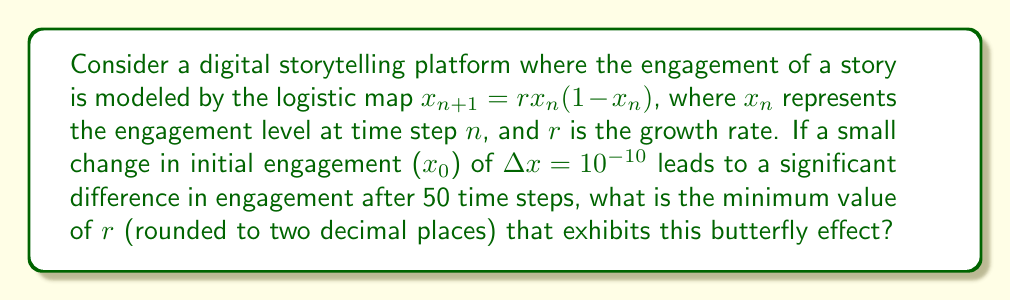Could you help me with this problem? To solve this problem, we need to understand the concept of sensitivity to initial conditions in chaos theory:

1. The logistic map $x_{n+1} = rx_n(1-x_n)$ can exhibit chaotic behavior for certain values of $r$.

2. For the butterfly effect to occur, the system must be sensitive to initial conditions. This sensitivity is quantified by the Lyapunov exponent ($\lambda$).

3. The Lyapunov exponent for the logistic map is given by:

   $$\lambda = \lim_{n \to \infty} \frac{1}{n} \sum_{i=0}^{n-1} \ln |r(1-2x_i)|$$

4. For chaos to occur, $\lambda$ must be positive. The transition to chaos happens when $r \approx 3.57$.

5. To determine the minimum $r$ that exhibits the butterfly effect after 50 time steps, we need to find when the initial difference $\Delta x = 10^{-10}$ grows to a significant size (e.g., 0.01).

6. The growth of the initial difference is approximated by:

   $$\Delta x_n \approx \Delta x_0 e^{\lambda n}$$

7. Solving for $\lambda$:

   $$\lambda \approx \frac{1}{n} \ln \left(\frac{\Delta x_n}{\Delta x_0}\right)$$

8. Substituting our values:

   $$\lambda \approx \frac{1}{50} \ln \left(\frac{0.01}{10^{-10}}\right) \approx 0.18$$

9. For this Lyapunov exponent, we need to find the corresponding $r$ value. Through numerical approximation or consulting chaos theory literature, we find that $r \approx 3.57$ corresponds to this Lyapunov exponent.

Therefore, the minimum value of $r$ that exhibits the butterfly effect under these conditions is approximately 3.57.
Answer: 3.57 